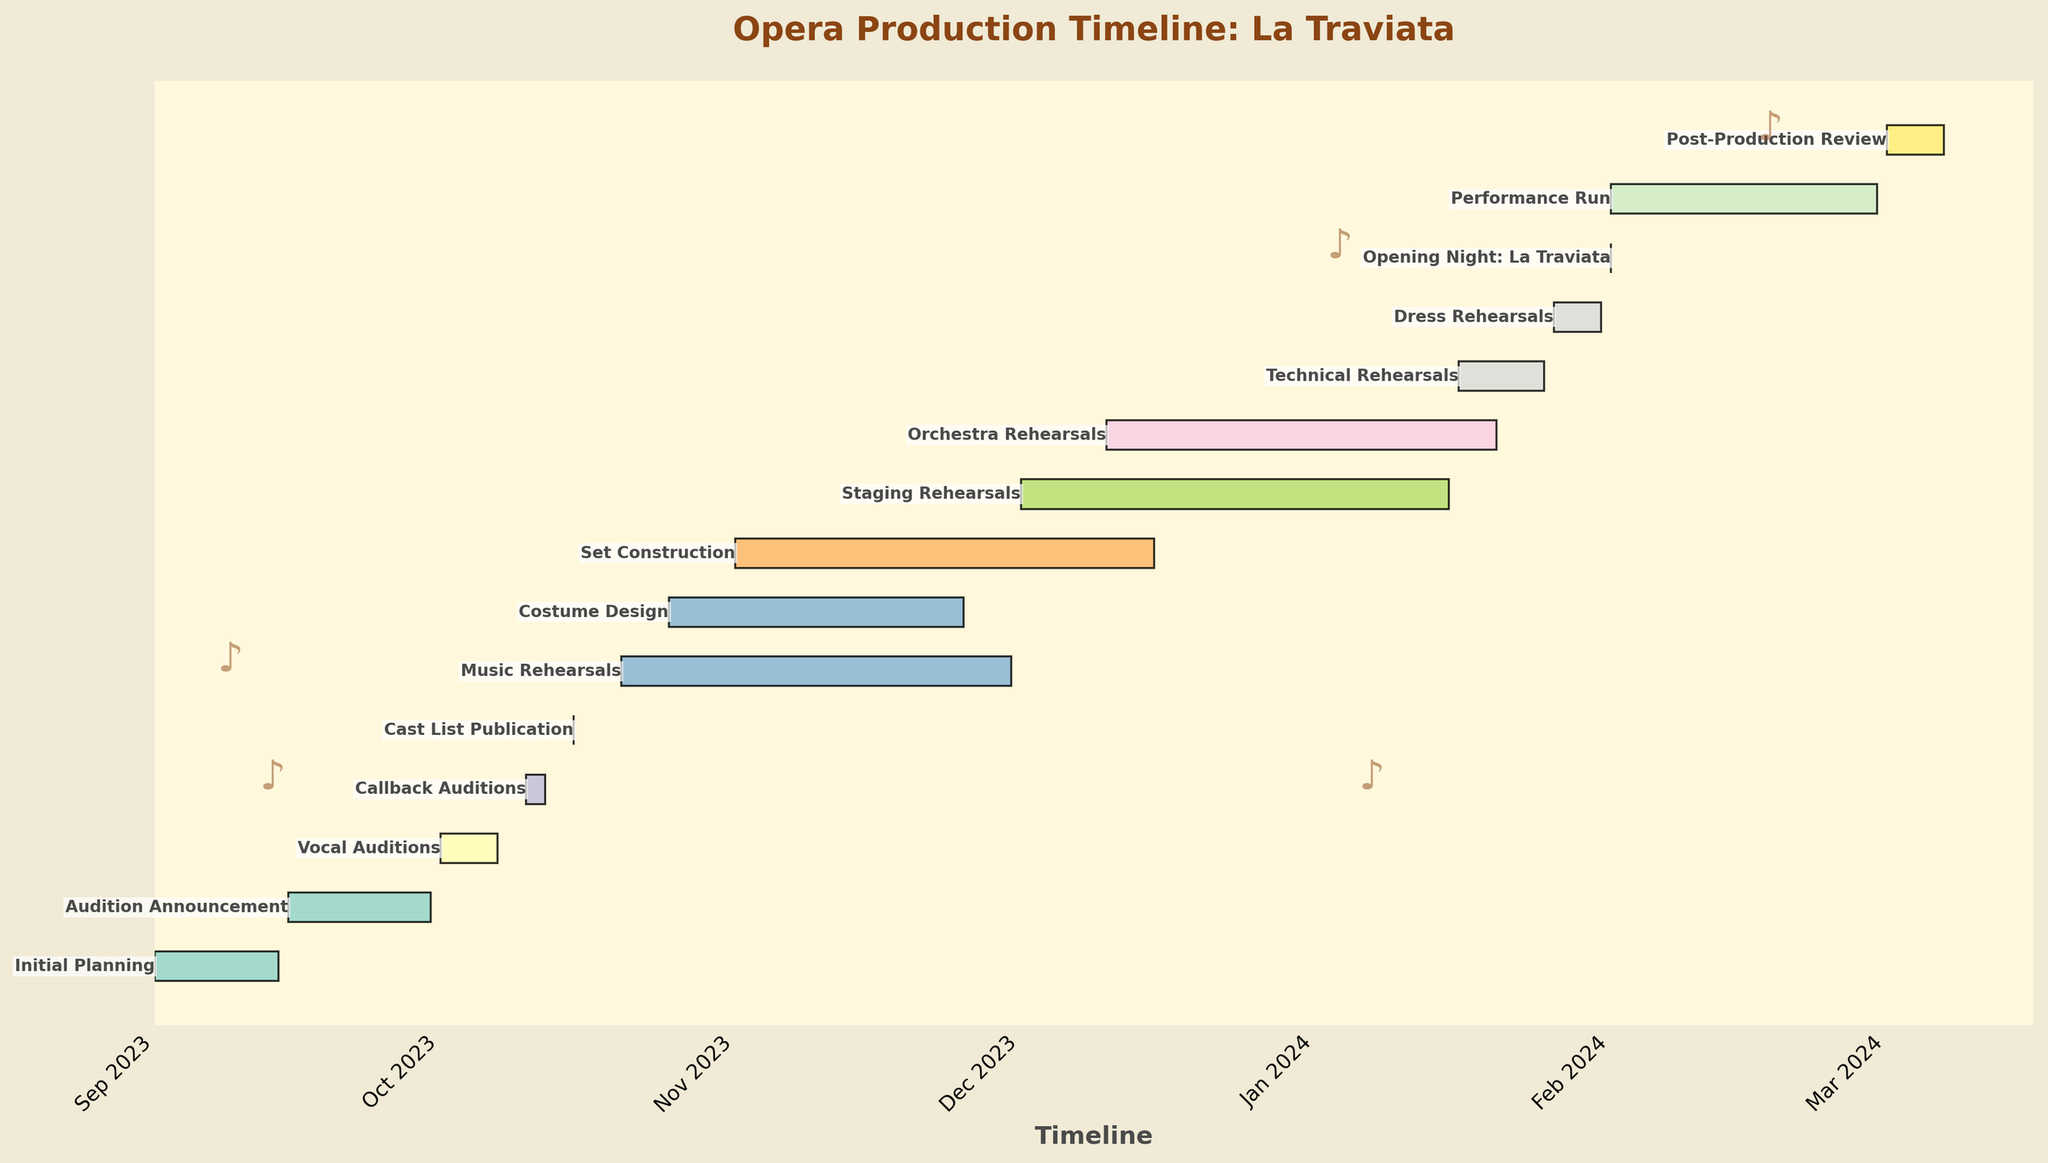What is the title of the Gantt Chart? The title is usually displayed prominently at the top of the chart to provide a summary of what the chart represents. In this chart, it's likely to be descriptive of the timeline it represents.
Answer: Opera Production Timeline: La Traviata What task starts immediately after "Initial Planning"? To find the next task, look at the timeline after the end of "Initial Planning," which ends on 2023-09-14. The next task to start after this date would be what we are looking for.
Answer: Audition Announcement How long is the "Vocal Auditions" period in days? The duration of a task can be found by subtracting the start date from the end date. "Vocal Auditions" start on 2023-10-01 and end on 2023-10-07. So, 2023-10-07 - 2023-10-01 gives us 6 days.
Answer: 6 days Which task lasts the longest and how many days does it last? To determine this, we need to look at the start and end dates of all tasks and calculate the duration of each. The longest duration among them will be the answer.
Answer: Staging Rehearsals with 46 days (2023-12-01 to 2024-01-15) When does the "Dress Rehearsals" task begin? The start date of a specific task can be directly read from the chart by locating the task and referring to the timeline. For "Dress Rehearsals," it begins on 2024-01-26.
Answer: 2024-01-26 During which month(s) does the "Costume Design" task occur? By observing the start date of 2023-10-25 and the end date of 2023-11-25 of the "Costume Design" task, we can see that it spans two months: October and November.
Answer: October and November Which task overlaps with both "Set Construction" and "Music Rehearsals"? To find overlapping tasks, look at the timeline. "Set Construction" runs from 2023-11-01 to 2023-12-15, and "Music Rehearsals" runs from 2023-10-20 to 2023-11-30. The task overlapping both is "Costume Design".
Answer: Costume Design How many days do "Technical Rehearsals" and "Dress Rehearsals" together span? Sum the durations of both tasks. "Technical Rehearsals" is from 2024-01-16 to 2024-01-25 (9 days), and "Dress Rehearsals" is from 2024-01-26 to 2024-01-31 (5 days). The total is 9 + 5 = 14 days.
Answer: 14 days Which task has the shortest duration and what is its duration? To find the shortest task, examine their durations. The "Cast List Publication" has just one day, which is the shortest.
Answer: Cast List Publication with 1 day When does the overall timeline for the opera production begin and end? Look at the earliest start date and the latest end date among all tasks. The timeline begins on 2023-09-01 and ends on 2024-03-07.
Answer: 2023-09-01 to 2024-03-07 